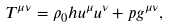<formula> <loc_0><loc_0><loc_500><loc_500>T ^ { \mu \nu } = \rho _ { 0 } h u ^ { \mu } u ^ { \nu } + p g ^ { \mu \nu } ,</formula> 